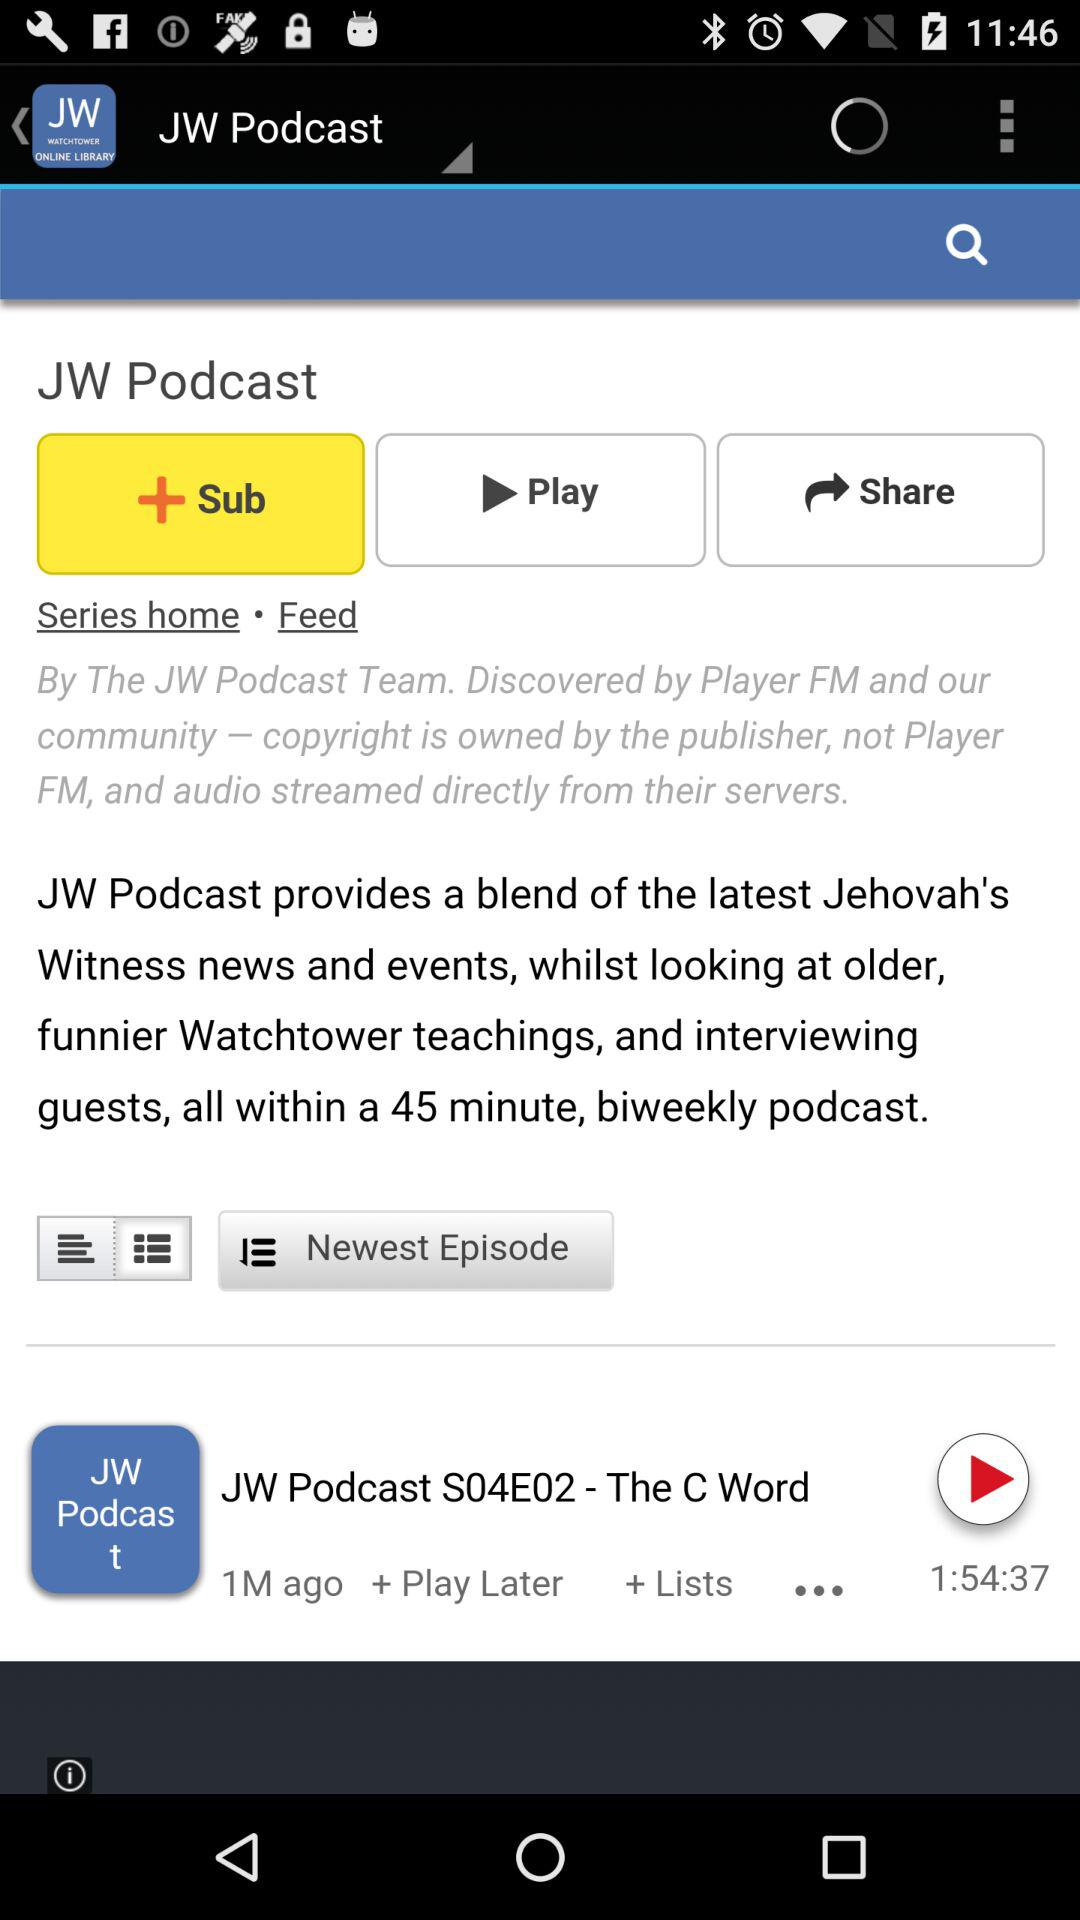Who is the host of "JW Podcast"?
When the provided information is insufficient, respond with <no answer>. <no answer> 